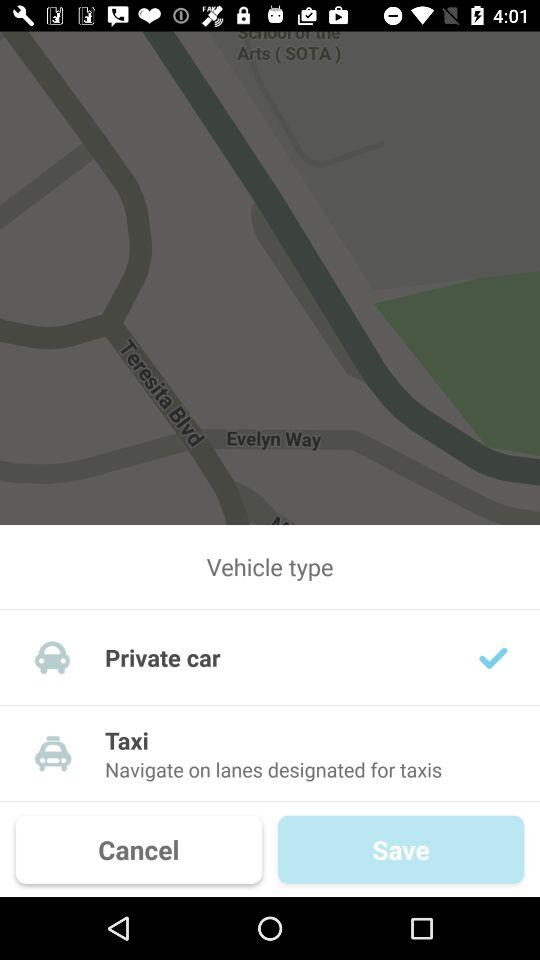Which options are there in "Vehicle type"? The options are "Private car" and "Taxi". 